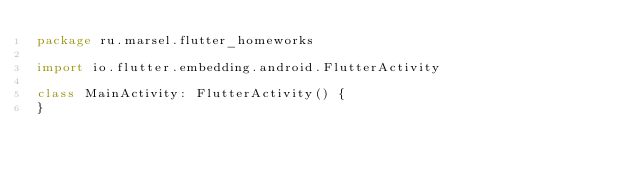<code> <loc_0><loc_0><loc_500><loc_500><_Kotlin_>package ru.marsel.flutter_homeworks

import io.flutter.embedding.android.FlutterActivity

class MainActivity: FlutterActivity() {
}
</code> 